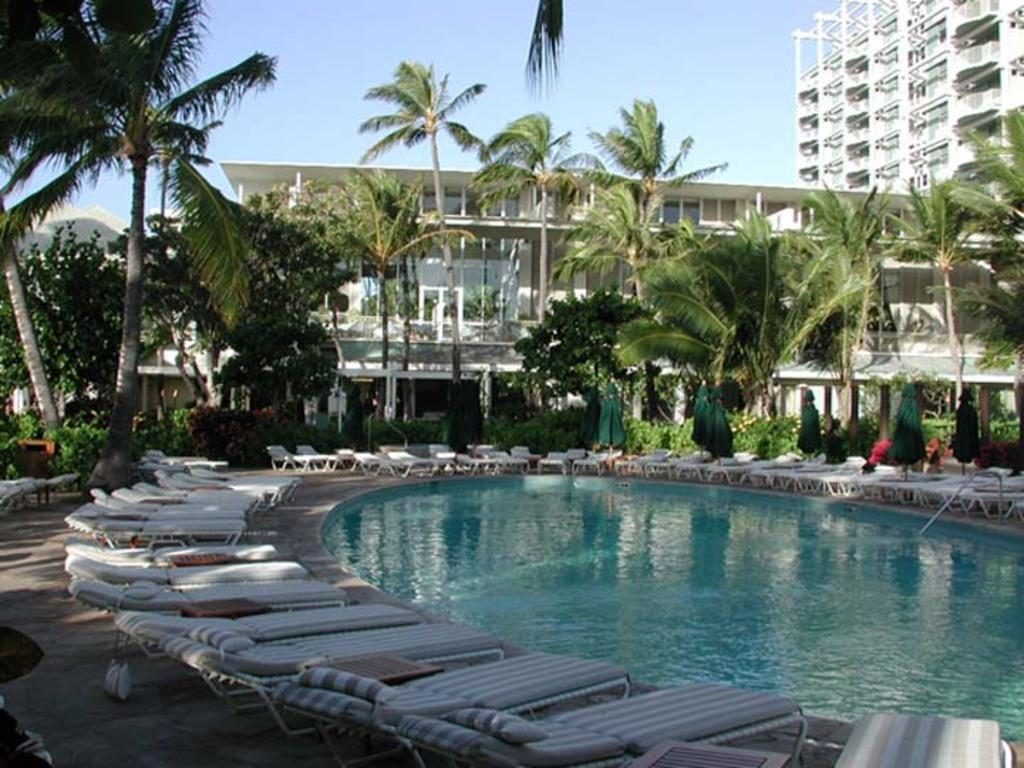What is the primary element in the image? There is water in the image. What objects are near the water? There are chairs on the ground beside the water. What structures can be seen in the image? There are buildings visible in the image. What type of vegetation is present in the image? Trees and plants are visible in the image. Can you describe the unspecified objects in the image? Unfortunately, the facts do not specify the nature of these objects. What is visible in the background of the image? The sky is visible in the background of the image. Can you tell me how many bikes are submerged in the quicksand in the image? There is no quicksand or bike present in the image; it features water, chairs, buildings, trees, plants, and unspecified objects. 